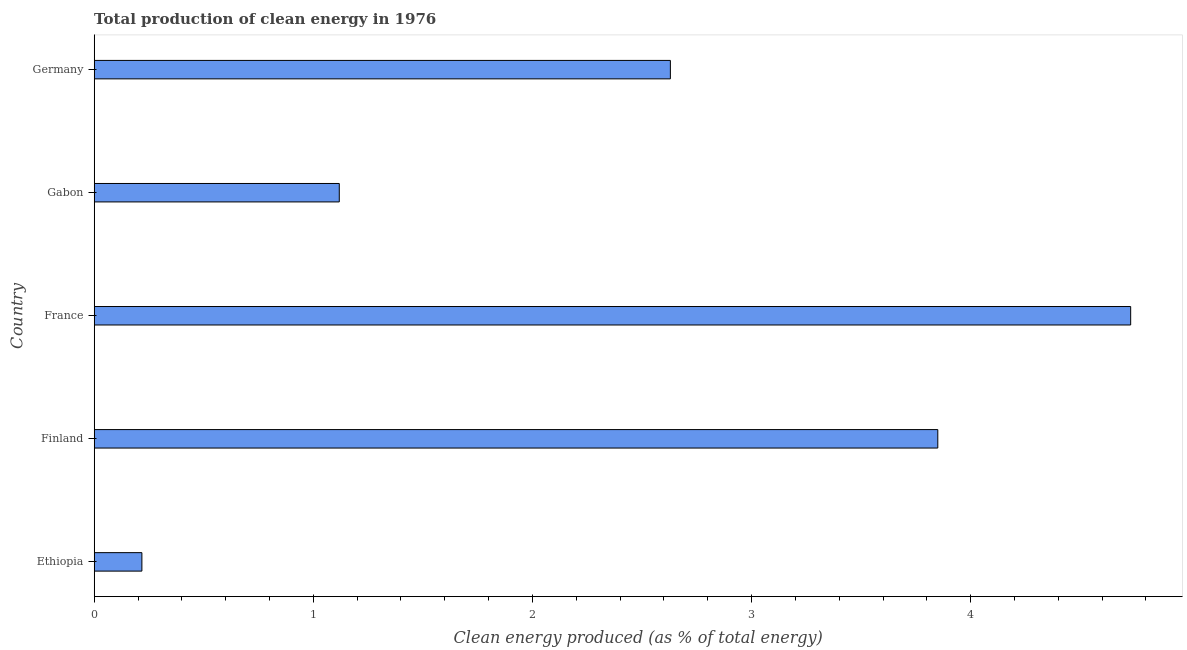Does the graph contain grids?
Make the answer very short. No. What is the title of the graph?
Provide a succinct answer. Total production of clean energy in 1976. What is the label or title of the X-axis?
Your response must be concise. Clean energy produced (as % of total energy). What is the production of clean energy in Ethiopia?
Give a very brief answer. 0.22. Across all countries, what is the maximum production of clean energy?
Offer a very short reply. 4.73. Across all countries, what is the minimum production of clean energy?
Ensure brevity in your answer.  0.22. In which country was the production of clean energy minimum?
Keep it short and to the point. Ethiopia. What is the sum of the production of clean energy?
Ensure brevity in your answer.  12.55. What is the difference between the production of clean energy in Ethiopia and Gabon?
Provide a short and direct response. -0.9. What is the average production of clean energy per country?
Provide a short and direct response. 2.51. What is the median production of clean energy?
Make the answer very short. 2.63. What is the ratio of the production of clean energy in France to that in Gabon?
Ensure brevity in your answer.  4.23. What is the difference between the highest and the second highest production of clean energy?
Offer a terse response. 0.88. Is the sum of the production of clean energy in Ethiopia and Gabon greater than the maximum production of clean energy across all countries?
Make the answer very short. No. What is the difference between the highest and the lowest production of clean energy?
Provide a succinct answer. 4.51. In how many countries, is the production of clean energy greater than the average production of clean energy taken over all countries?
Offer a very short reply. 3. How many bars are there?
Your answer should be compact. 5. How many countries are there in the graph?
Offer a terse response. 5. What is the difference between two consecutive major ticks on the X-axis?
Your answer should be compact. 1. What is the Clean energy produced (as % of total energy) of Ethiopia?
Your answer should be compact. 0.22. What is the Clean energy produced (as % of total energy) in Finland?
Keep it short and to the point. 3.85. What is the Clean energy produced (as % of total energy) of France?
Provide a short and direct response. 4.73. What is the Clean energy produced (as % of total energy) of Gabon?
Offer a very short reply. 1.12. What is the Clean energy produced (as % of total energy) of Germany?
Your answer should be compact. 2.63. What is the difference between the Clean energy produced (as % of total energy) in Ethiopia and Finland?
Offer a very short reply. -3.63. What is the difference between the Clean energy produced (as % of total energy) in Ethiopia and France?
Give a very brief answer. -4.51. What is the difference between the Clean energy produced (as % of total energy) in Ethiopia and Gabon?
Keep it short and to the point. -0.9. What is the difference between the Clean energy produced (as % of total energy) in Ethiopia and Germany?
Keep it short and to the point. -2.41. What is the difference between the Clean energy produced (as % of total energy) in Finland and France?
Ensure brevity in your answer.  -0.88. What is the difference between the Clean energy produced (as % of total energy) in Finland and Gabon?
Make the answer very short. 2.73. What is the difference between the Clean energy produced (as % of total energy) in Finland and Germany?
Make the answer very short. 1.22. What is the difference between the Clean energy produced (as % of total energy) in France and Gabon?
Provide a short and direct response. 3.61. What is the difference between the Clean energy produced (as % of total energy) in France and Germany?
Provide a succinct answer. 2.1. What is the difference between the Clean energy produced (as % of total energy) in Gabon and Germany?
Give a very brief answer. -1.51. What is the ratio of the Clean energy produced (as % of total energy) in Ethiopia to that in Finland?
Give a very brief answer. 0.06. What is the ratio of the Clean energy produced (as % of total energy) in Ethiopia to that in France?
Give a very brief answer. 0.05. What is the ratio of the Clean energy produced (as % of total energy) in Ethiopia to that in Gabon?
Offer a very short reply. 0.2. What is the ratio of the Clean energy produced (as % of total energy) in Ethiopia to that in Germany?
Provide a short and direct response. 0.08. What is the ratio of the Clean energy produced (as % of total energy) in Finland to that in France?
Ensure brevity in your answer.  0.81. What is the ratio of the Clean energy produced (as % of total energy) in Finland to that in Gabon?
Your answer should be very brief. 3.44. What is the ratio of the Clean energy produced (as % of total energy) in Finland to that in Germany?
Offer a terse response. 1.46. What is the ratio of the Clean energy produced (as % of total energy) in France to that in Gabon?
Give a very brief answer. 4.23. What is the ratio of the Clean energy produced (as % of total energy) in France to that in Germany?
Offer a terse response. 1.8. What is the ratio of the Clean energy produced (as % of total energy) in Gabon to that in Germany?
Give a very brief answer. 0.42. 